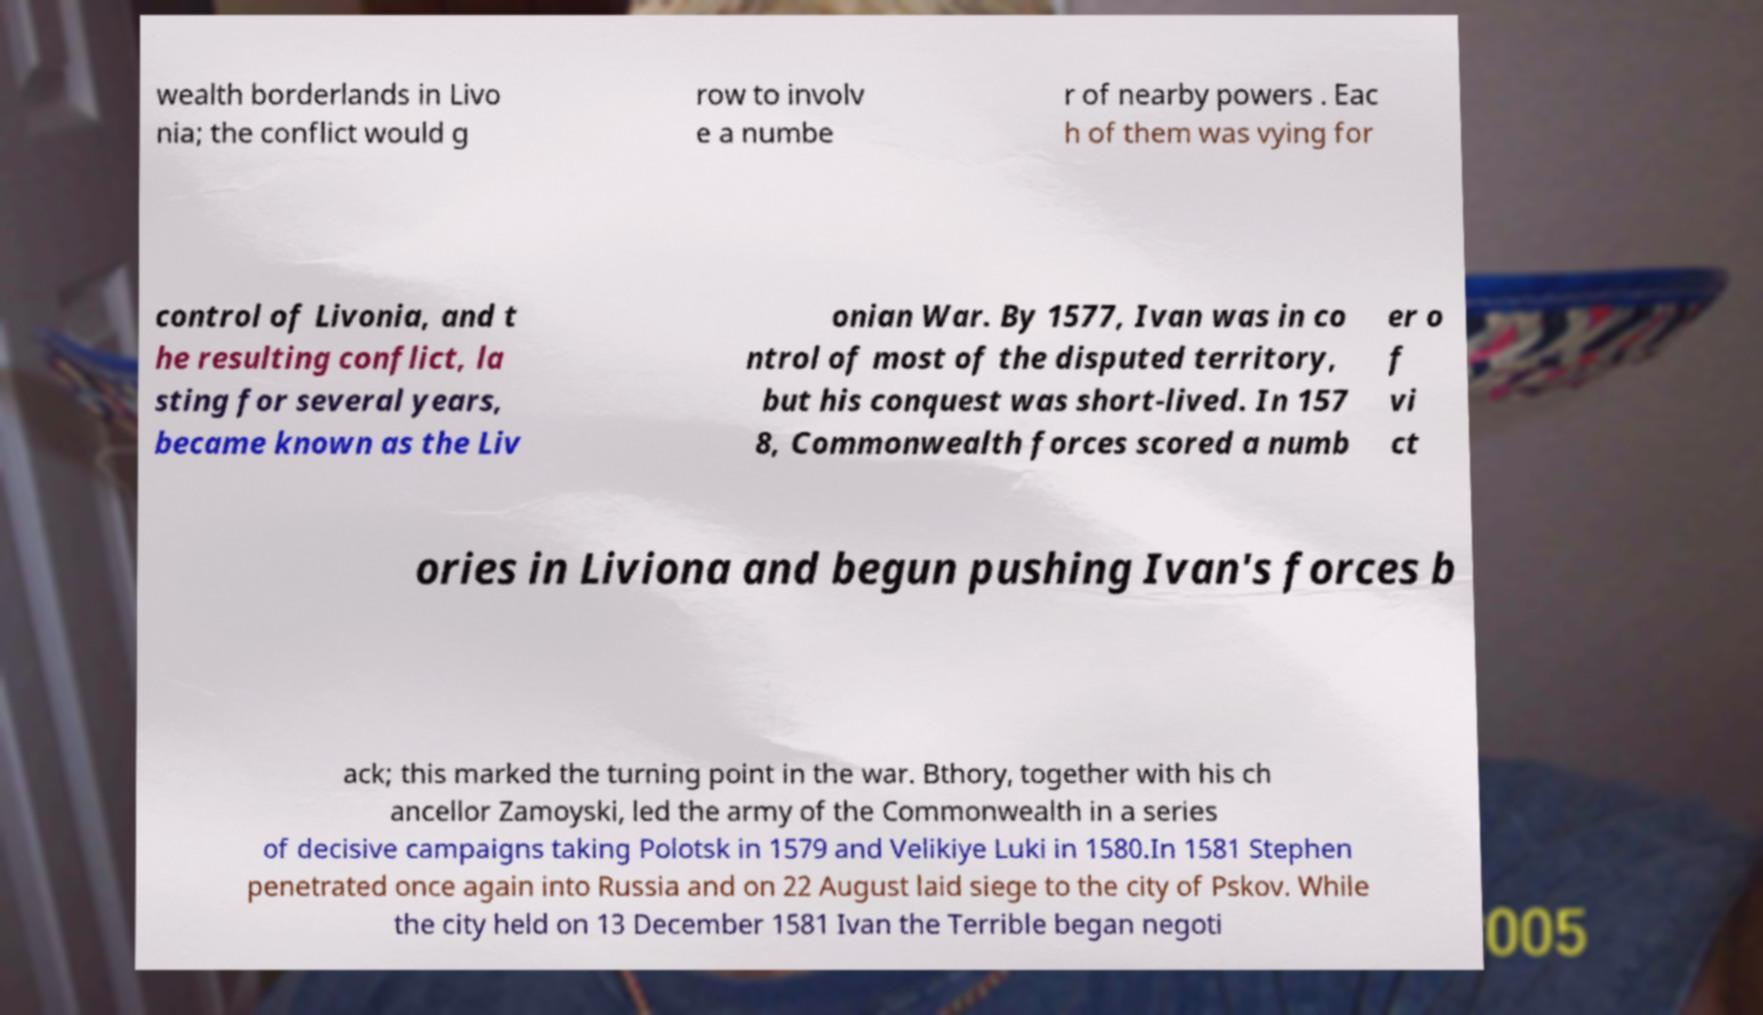Please read and relay the text visible in this image. What does it say? wealth borderlands in Livo nia; the conflict would g row to involv e a numbe r of nearby powers . Eac h of them was vying for control of Livonia, and t he resulting conflict, la sting for several years, became known as the Liv onian War. By 1577, Ivan was in co ntrol of most of the disputed territory, but his conquest was short-lived. In 157 8, Commonwealth forces scored a numb er o f vi ct ories in Liviona and begun pushing Ivan's forces b ack; this marked the turning point in the war. Bthory, together with his ch ancellor Zamoyski, led the army of the Commonwealth in a series of decisive campaigns taking Polotsk in 1579 and Velikiye Luki in 1580.In 1581 Stephen penetrated once again into Russia and on 22 August laid siege to the city of Pskov. While the city held on 13 December 1581 Ivan the Terrible began negoti 